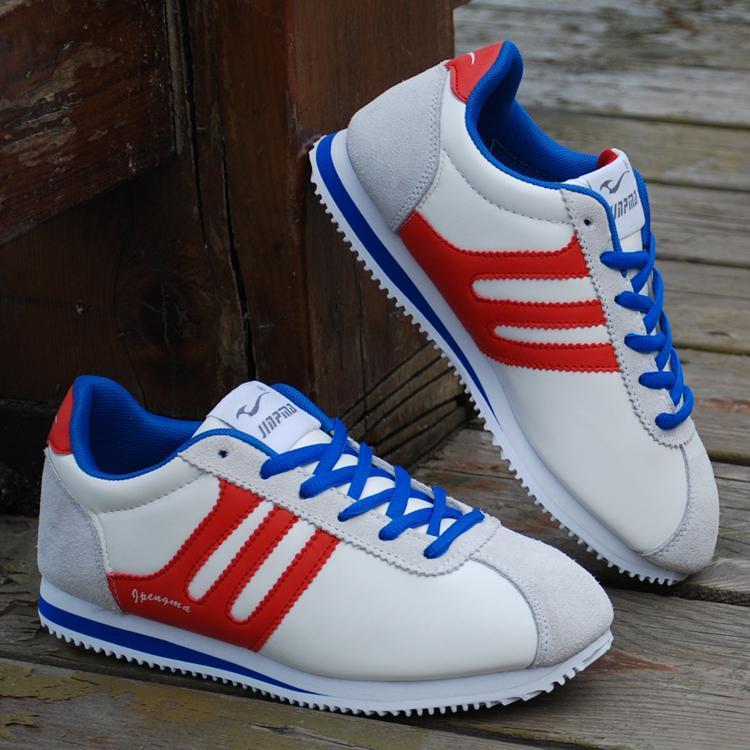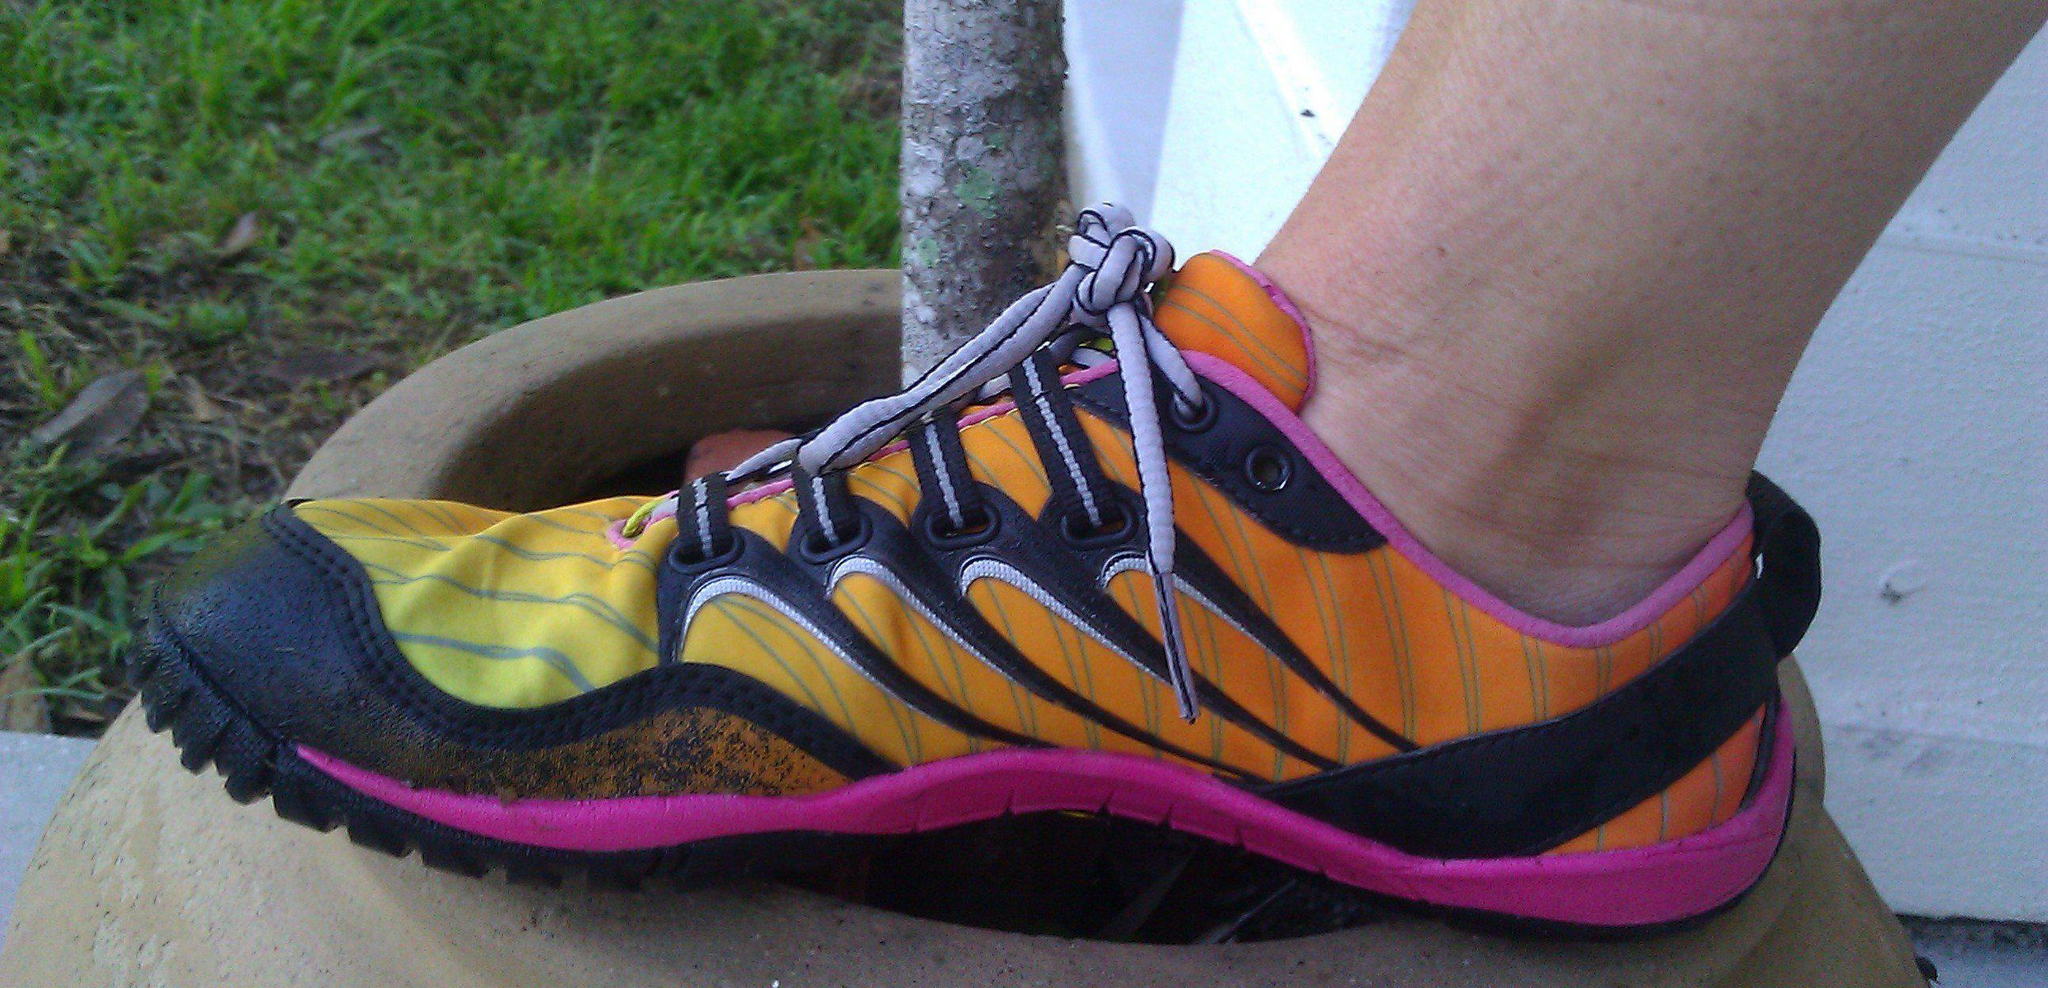The first image is the image on the left, the second image is the image on the right. For the images shown, is this caption "In one image, at least one shoe is being worn by a human." true? Answer yes or no. Yes. 